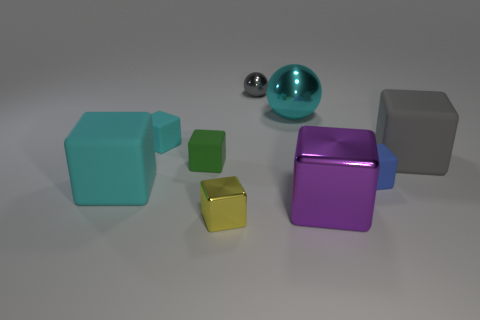There is a tiny cyan block; are there any big purple shiny objects behind it?
Make the answer very short. No. There is a large cube that is the same color as the tiny ball; what material is it?
Offer a very short reply. Rubber. Is the material of the small cyan object that is on the left side of the small yellow metal block the same as the big gray block?
Make the answer very short. Yes. There is a large rubber object in front of the rubber cube right of the blue block; are there any tiny cyan cubes that are to the left of it?
Make the answer very short. No. How many cylinders are either cyan things or green matte things?
Your answer should be very brief. 0. What is the material of the cyan block that is behind the big cyan cube?
Make the answer very short. Rubber. There is a thing that is the same color as the small metallic sphere; what is its size?
Give a very brief answer. Large. Does the rubber object that is behind the large gray object have the same color as the large metallic thing in front of the green matte thing?
Offer a very short reply. No. How many things are either metal balls or blue things?
Provide a short and direct response. 3. What number of other things are the same shape as the green rubber thing?
Offer a very short reply. 6. 